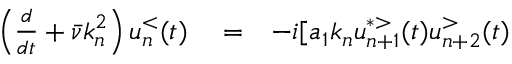<formula> <loc_0><loc_0><loc_500><loc_500>\begin{array} { r l r } { \left ( \frac { d } { d t } + \bar { \nu } k _ { n } ^ { 2 } \right ) u _ { n } ^ { < } ( t ) } & = } & { - i [ a _ { 1 } k _ { n } u _ { n + 1 } ^ { * > } ( t ) u _ { n + 2 } ^ { > } ( t ) } \end{array}</formula> 